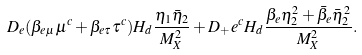<formula> <loc_0><loc_0><loc_500><loc_500>D _ { e } ( \beta _ { e \mu } \mu ^ { c } + \beta _ { e \tau } \tau ^ { c } ) H _ { d } \frac { \eta _ { 1 } \bar { \eta } _ { 2 } } { M _ { X } ^ { 2 } } + D _ { + } e ^ { c } H _ { d } \frac { \beta _ { e } \eta _ { 2 } ^ { 2 } + \bar { \beta } _ { e } \bar { \eta } _ { 2 } ^ { 2 } } { M _ { X } ^ { 2 } } .</formula> 